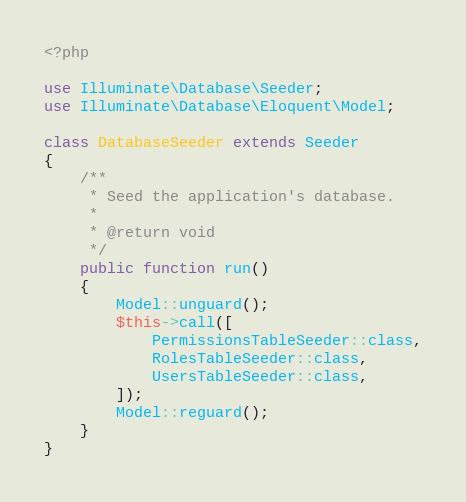Convert code to text. <code><loc_0><loc_0><loc_500><loc_500><_PHP_><?php

use Illuminate\Database\Seeder;
use Illuminate\Database\Eloquent\Model;

class DatabaseSeeder extends Seeder
{
    /**
     * Seed the application's database.
     *
     * @return void
     */
    public function run()
    {
        Model::unguard();
        $this->call([
            PermissionsTableSeeder::class,
            RolesTableSeeder::class,
            UsersTableSeeder::class,
        ]);
        Model::reguard();
    }
}
</code> 